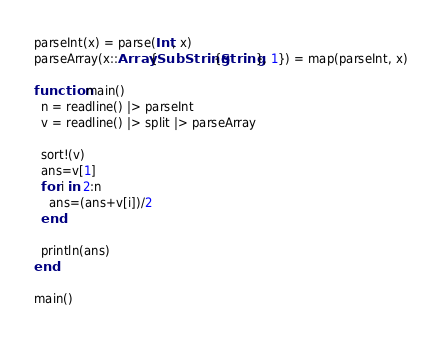<code> <loc_0><loc_0><loc_500><loc_500><_Julia_>parseInt(x) = parse(Int, x)
parseArray(x::Array{SubString{String}, 1}) = map(parseInt, x)

function main()
  n = readline() |> parseInt
  v = readline() |> split |> parseArray

  sort!(v)
  ans=v[1]
  for i in 2:n
    ans=(ans+v[i])/2
  end

  println(ans)
end

main()
</code> 